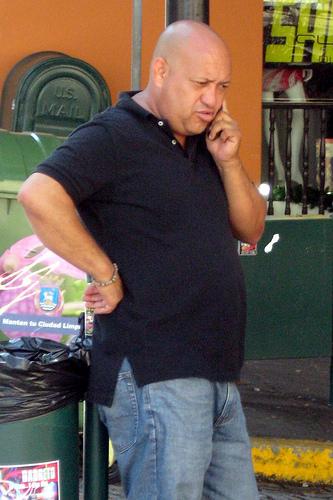What is the man doing?
Be succinct. Talking on phone. Which hand is he holding the cell phone with?
Quick response, please. Left. Are you able to tell what the man is doing from the photo?
Short answer required. Yes. 